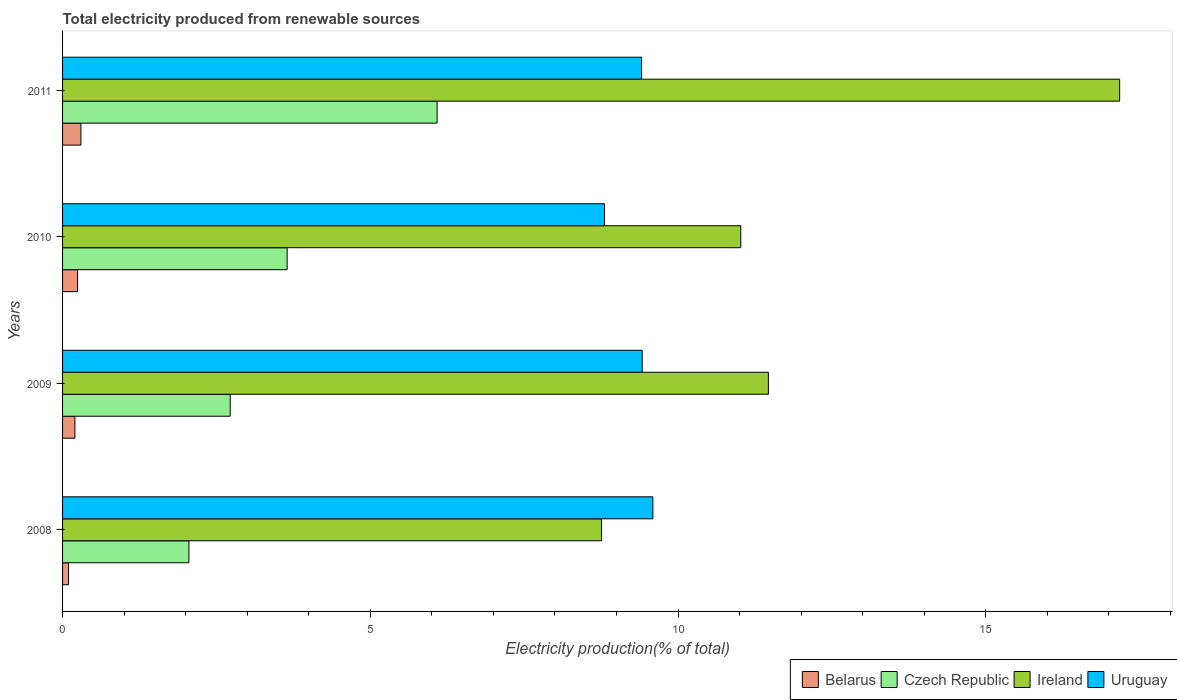How many different coloured bars are there?
Your response must be concise. 4. How many groups of bars are there?
Ensure brevity in your answer.  4. Are the number of bars per tick equal to the number of legend labels?
Your response must be concise. Yes. How many bars are there on the 3rd tick from the bottom?
Offer a terse response. 4. In how many cases, is the number of bars for a given year not equal to the number of legend labels?
Make the answer very short. 0. What is the total electricity produced in Ireland in 2011?
Offer a terse response. 17.17. Across all years, what is the maximum total electricity produced in Ireland?
Make the answer very short. 17.17. Across all years, what is the minimum total electricity produced in Ireland?
Offer a very short reply. 8.76. In which year was the total electricity produced in Belarus maximum?
Keep it short and to the point. 2011. In which year was the total electricity produced in Ireland minimum?
Offer a very short reply. 2008. What is the total total electricity produced in Ireland in the graph?
Provide a short and direct response. 48.42. What is the difference between the total electricity produced in Czech Republic in 2009 and that in 2010?
Give a very brief answer. -0.93. What is the difference between the total electricity produced in Uruguay in 2010 and the total electricity produced in Ireland in 2009?
Offer a very short reply. -2.66. What is the average total electricity produced in Ireland per year?
Your response must be concise. 12.1. In the year 2008, what is the difference between the total electricity produced in Ireland and total electricity produced in Belarus?
Your answer should be very brief. 8.66. What is the ratio of the total electricity produced in Belarus in 2008 to that in 2011?
Ensure brevity in your answer.  0.33. What is the difference between the highest and the second highest total electricity produced in Belarus?
Make the answer very short. 0.05. What is the difference between the highest and the lowest total electricity produced in Czech Republic?
Your answer should be compact. 4.03. What does the 3rd bar from the top in 2009 represents?
Keep it short and to the point. Czech Republic. What does the 4th bar from the bottom in 2008 represents?
Your answer should be very brief. Uruguay. Are all the bars in the graph horizontal?
Your answer should be very brief. Yes. How many years are there in the graph?
Give a very brief answer. 4. What is the difference between two consecutive major ticks on the X-axis?
Offer a terse response. 5. Does the graph contain any zero values?
Offer a terse response. No. How are the legend labels stacked?
Make the answer very short. Horizontal. What is the title of the graph?
Keep it short and to the point. Total electricity produced from renewable sources. Does "St. Lucia" appear as one of the legend labels in the graph?
Ensure brevity in your answer.  No. What is the Electricity production(% of total) in Belarus in 2008?
Provide a succinct answer. 0.1. What is the Electricity production(% of total) of Czech Republic in 2008?
Your answer should be very brief. 2.05. What is the Electricity production(% of total) in Ireland in 2008?
Provide a short and direct response. 8.76. What is the Electricity production(% of total) of Uruguay in 2008?
Keep it short and to the point. 9.59. What is the Electricity production(% of total) in Belarus in 2009?
Ensure brevity in your answer.  0.2. What is the Electricity production(% of total) of Czech Republic in 2009?
Give a very brief answer. 2.72. What is the Electricity production(% of total) in Ireland in 2009?
Your response must be concise. 11.47. What is the Electricity production(% of total) of Uruguay in 2009?
Keep it short and to the point. 9.42. What is the Electricity production(% of total) of Belarus in 2010?
Provide a short and direct response. 0.24. What is the Electricity production(% of total) of Czech Republic in 2010?
Keep it short and to the point. 3.65. What is the Electricity production(% of total) of Ireland in 2010?
Your answer should be very brief. 11.02. What is the Electricity production(% of total) of Uruguay in 2010?
Ensure brevity in your answer.  8.8. What is the Electricity production(% of total) of Belarus in 2011?
Give a very brief answer. 0.3. What is the Electricity production(% of total) in Czech Republic in 2011?
Ensure brevity in your answer.  6.08. What is the Electricity production(% of total) in Ireland in 2011?
Make the answer very short. 17.17. What is the Electricity production(% of total) in Uruguay in 2011?
Offer a terse response. 9.41. Across all years, what is the maximum Electricity production(% of total) in Belarus?
Ensure brevity in your answer.  0.3. Across all years, what is the maximum Electricity production(% of total) in Czech Republic?
Offer a terse response. 6.08. Across all years, what is the maximum Electricity production(% of total) of Ireland?
Keep it short and to the point. 17.17. Across all years, what is the maximum Electricity production(% of total) of Uruguay?
Offer a very short reply. 9.59. Across all years, what is the minimum Electricity production(% of total) in Belarus?
Give a very brief answer. 0.1. Across all years, what is the minimum Electricity production(% of total) of Czech Republic?
Your answer should be compact. 2.05. Across all years, what is the minimum Electricity production(% of total) of Ireland?
Keep it short and to the point. 8.76. Across all years, what is the minimum Electricity production(% of total) in Uruguay?
Provide a short and direct response. 8.8. What is the total Electricity production(% of total) in Belarus in the graph?
Your response must be concise. 0.84. What is the total Electricity production(% of total) in Czech Republic in the graph?
Your answer should be very brief. 14.51. What is the total Electricity production(% of total) of Ireland in the graph?
Keep it short and to the point. 48.42. What is the total Electricity production(% of total) of Uruguay in the graph?
Your answer should be very brief. 37.22. What is the difference between the Electricity production(% of total) of Belarus in 2008 and that in 2009?
Your answer should be compact. -0.1. What is the difference between the Electricity production(% of total) of Czech Republic in 2008 and that in 2009?
Ensure brevity in your answer.  -0.67. What is the difference between the Electricity production(% of total) of Ireland in 2008 and that in 2009?
Offer a very short reply. -2.71. What is the difference between the Electricity production(% of total) in Uruguay in 2008 and that in 2009?
Provide a succinct answer. 0.17. What is the difference between the Electricity production(% of total) in Belarus in 2008 and that in 2010?
Your answer should be very brief. -0.15. What is the difference between the Electricity production(% of total) of Czech Republic in 2008 and that in 2010?
Provide a succinct answer. -1.6. What is the difference between the Electricity production(% of total) of Ireland in 2008 and that in 2010?
Your answer should be very brief. -2.26. What is the difference between the Electricity production(% of total) in Uruguay in 2008 and that in 2010?
Your answer should be very brief. 0.79. What is the difference between the Electricity production(% of total) in Belarus in 2008 and that in 2011?
Your answer should be compact. -0.2. What is the difference between the Electricity production(% of total) in Czech Republic in 2008 and that in 2011?
Provide a succinct answer. -4.03. What is the difference between the Electricity production(% of total) of Ireland in 2008 and that in 2011?
Provide a succinct answer. -8.42. What is the difference between the Electricity production(% of total) of Uruguay in 2008 and that in 2011?
Give a very brief answer. 0.18. What is the difference between the Electricity production(% of total) in Belarus in 2009 and that in 2010?
Your answer should be very brief. -0.04. What is the difference between the Electricity production(% of total) in Czech Republic in 2009 and that in 2010?
Offer a very short reply. -0.93. What is the difference between the Electricity production(% of total) in Ireland in 2009 and that in 2010?
Offer a terse response. 0.45. What is the difference between the Electricity production(% of total) of Uruguay in 2009 and that in 2010?
Provide a short and direct response. 0.61. What is the difference between the Electricity production(% of total) of Belarus in 2009 and that in 2011?
Your answer should be compact. -0.1. What is the difference between the Electricity production(% of total) of Czech Republic in 2009 and that in 2011?
Provide a short and direct response. -3.36. What is the difference between the Electricity production(% of total) in Ireland in 2009 and that in 2011?
Give a very brief answer. -5.71. What is the difference between the Electricity production(% of total) of Uruguay in 2009 and that in 2011?
Your response must be concise. 0.01. What is the difference between the Electricity production(% of total) in Belarus in 2010 and that in 2011?
Ensure brevity in your answer.  -0.05. What is the difference between the Electricity production(% of total) in Czech Republic in 2010 and that in 2011?
Offer a very short reply. -2.44. What is the difference between the Electricity production(% of total) of Ireland in 2010 and that in 2011?
Ensure brevity in your answer.  -6.16. What is the difference between the Electricity production(% of total) in Uruguay in 2010 and that in 2011?
Provide a short and direct response. -0.6. What is the difference between the Electricity production(% of total) in Belarus in 2008 and the Electricity production(% of total) in Czech Republic in 2009?
Provide a succinct answer. -2.63. What is the difference between the Electricity production(% of total) in Belarus in 2008 and the Electricity production(% of total) in Ireland in 2009?
Provide a succinct answer. -11.37. What is the difference between the Electricity production(% of total) of Belarus in 2008 and the Electricity production(% of total) of Uruguay in 2009?
Give a very brief answer. -9.32. What is the difference between the Electricity production(% of total) of Czech Republic in 2008 and the Electricity production(% of total) of Ireland in 2009?
Your response must be concise. -9.41. What is the difference between the Electricity production(% of total) of Czech Republic in 2008 and the Electricity production(% of total) of Uruguay in 2009?
Offer a very short reply. -7.36. What is the difference between the Electricity production(% of total) of Ireland in 2008 and the Electricity production(% of total) of Uruguay in 2009?
Make the answer very short. -0.66. What is the difference between the Electricity production(% of total) in Belarus in 2008 and the Electricity production(% of total) in Czech Republic in 2010?
Keep it short and to the point. -3.55. What is the difference between the Electricity production(% of total) of Belarus in 2008 and the Electricity production(% of total) of Ireland in 2010?
Offer a very short reply. -10.92. What is the difference between the Electricity production(% of total) of Belarus in 2008 and the Electricity production(% of total) of Uruguay in 2010?
Your answer should be compact. -8.71. What is the difference between the Electricity production(% of total) of Czech Republic in 2008 and the Electricity production(% of total) of Ireland in 2010?
Offer a terse response. -8.97. What is the difference between the Electricity production(% of total) of Czech Republic in 2008 and the Electricity production(% of total) of Uruguay in 2010?
Offer a terse response. -6.75. What is the difference between the Electricity production(% of total) in Ireland in 2008 and the Electricity production(% of total) in Uruguay in 2010?
Offer a very short reply. -0.05. What is the difference between the Electricity production(% of total) of Belarus in 2008 and the Electricity production(% of total) of Czech Republic in 2011?
Your answer should be compact. -5.99. What is the difference between the Electricity production(% of total) in Belarus in 2008 and the Electricity production(% of total) in Ireland in 2011?
Your response must be concise. -17.08. What is the difference between the Electricity production(% of total) of Belarus in 2008 and the Electricity production(% of total) of Uruguay in 2011?
Make the answer very short. -9.31. What is the difference between the Electricity production(% of total) in Czech Republic in 2008 and the Electricity production(% of total) in Ireland in 2011?
Offer a very short reply. -15.12. What is the difference between the Electricity production(% of total) in Czech Republic in 2008 and the Electricity production(% of total) in Uruguay in 2011?
Your answer should be compact. -7.35. What is the difference between the Electricity production(% of total) of Ireland in 2008 and the Electricity production(% of total) of Uruguay in 2011?
Provide a short and direct response. -0.65. What is the difference between the Electricity production(% of total) of Belarus in 2009 and the Electricity production(% of total) of Czech Republic in 2010?
Your answer should be compact. -3.45. What is the difference between the Electricity production(% of total) in Belarus in 2009 and the Electricity production(% of total) in Ireland in 2010?
Give a very brief answer. -10.82. What is the difference between the Electricity production(% of total) of Belarus in 2009 and the Electricity production(% of total) of Uruguay in 2010?
Provide a succinct answer. -8.6. What is the difference between the Electricity production(% of total) in Czech Republic in 2009 and the Electricity production(% of total) in Ireland in 2010?
Ensure brevity in your answer.  -8.29. What is the difference between the Electricity production(% of total) of Czech Republic in 2009 and the Electricity production(% of total) of Uruguay in 2010?
Ensure brevity in your answer.  -6.08. What is the difference between the Electricity production(% of total) of Ireland in 2009 and the Electricity production(% of total) of Uruguay in 2010?
Your answer should be compact. 2.66. What is the difference between the Electricity production(% of total) of Belarus in 2009 and the Electricity production(% of total) of Czech Republic in 2011?
Ensure brevity in your answer.  -5.88. What is the difference between the Electricity production(% of total) of Belarus in 2009 and the Electricity production(% of total) of Ireland in 2011?
Keep it short and to the point. -16.97. What is the difference between the Electricity production(% of total) of Belarus in 2009 and the Electricity production(% of total) of Uruguay in 2011?
Your response must be concise. -9.21. What is the difference between the Electricity production(% of total) of Czech Republic in 2009 and the Electricity production(% of total) of Ireland in 2011?
Your response must be concise. -14.45. What is the difference between the Electricity production(% of total) of Czech Republic in 2009 and the Electricity production(% of total) of Uruguay in 2011?
Offer a terse response. -6.68. What is the difference between the Electricity production(% of total) in Ireland in 2009 and the Electricity production(% of total) in Uruguay in 2011?
Ensure brevity in your answer.  2.06. What is the difference between the Electricity production(% of total) in Belarus in 2010 and the Electricity production(% of total) in Czech Republic in 2011?
Your response must be concise. -5.84. What is the difference between the Electricity production(% of total) of Belarus in 2010 and the Electricity production(% of total) of Ireland in 2011?
Keep it short and to the point. -16.93. What is the difference between the Electricity production(% of total) in Belarus in 2010 and the Electricity production(% of total) in Uruguay in 2011?
Ensure brevity in your answer.  -9.16. What is the difference between the Electricity production(% of total) in Czech Republic in 2010 and the Electricity production(% of total) in Ireland in 2011?
Make the answer very short. -13.53. What is the difference between the Electricity production(% of total) of Czech Republic in 2010 and the Electricity production(% of total) of Uruguay in 2011?
Provide a succinct answer. -5.76. What is the difference between the Electricity production(% of total) in Ireland in 2010 and the Electricity production(% of total) in Uruguay in 2011?
Offer a very short reply. 1.61. What is the average Electricity production(% of total) in Belarus per year?
Offer a very short reply. 0.21. What is the average Electricity production(% of total) in Czech Republic per year?
Your answer should be very brief. 3.63. What is the average Electricity production(% of total) of Ireland per year?
Your response must be concise. 12.1. What is the average Electricity production(% of total) of Uruguay per year?
Your answer should be compact. 9.3. In the year 2008, what is the difference between the Electricity production(% of total) of Belarus and Electricity production(% of total) of Czech Republic?
Provide a short and direct response. -1.96. In the year 2008, what is the difference between the Electricity production(% of total) in Belarus and Electricity production(% of total) in Ireland?
Provide a succinct answer. -8.66. In the year 2008, what is the difference between the Electricity production(% of total) in Belarus and Electricity production(% of total) in Uruguay?
Keep it short and to the point. -9.49. In the year 2008, what is the difference between the Electricity production(% of total) of Czech Republic and Electricity production(% of total) of Ireland?
Your response must be concise. -6.7. In the year 2008, what is the difference between the Electricity production(% of total) in Czech Republic and Electricity production(% of total) in Uruguay?
Provide a short and direct response. -7.54. In the year 2008, what is the difference between the Electricity production(% of total) of Ireland and Electricity production(% of total) of Uruguay?
Ensure brevity in your answer.  -0.83. In the year 2009, what is the difference between the Electricity production(% of total) in Belarus and Electricity production(% of total) in Czech Republic?
Make the answer very short. -2.52. In the year 2009, what is the difference between the Electricity production(% of total) of Belarus and Electricity production(% of total) of Ireland?
Make the answer very short. -11.27. In the year 2009, what is the difference between the Electricity production(% of total) of Belarus and Electricity production(% of total) of Uruguay?
Your response must be concise. -9.22. In the year 2009, what is the difference between the Electricity production(% of total) of Czech Republic and Electricity production(% of total) of Ireland?
Provide a short and direct response. -8.74. In the year 2009, what is the difference between the Electricity production(% of total) in Czech Republic and Electricity production(% of total) in Uruguay?
Provide a short and direct response. -6.69. In the year 2009, what is the difference between the Electricity production(% of total) of Ireland and Electricity production(% of total) of Uruguay?
Your response must be concise. 2.05. In the year 2010, what is the difference between the Electricity production(% of total) in Belarus and Electricity production(% of total) in Czech Republic?
Make the answer very short. -3.41. In the year 2010, what is the difference between the Electricity production(% of total) in Belarus and Electricity production(% of total) in Ireland?
Provide a succinct answer. -10.77. In the year 2010, what is the difference between the Electricity production(% of total) of Belarus and Electricity production(% of total) of Uruguay?
Your answer should be very brief. -8.56. In the year 2010, what is the difference between the Electricity production(% of total) in Czech Republic and Electricity production(% of total) in Ireland?
Ensure brevity in your answer.  -7.37. In the year 2010, what is the difference between the Electricity production(% of total) in Czech Republic and Electricity production(% of total) in Uruguay?
Ensure brevity in your answer.  -5.16. In the year 2010, what is the difference between the Electricity production(% of total) of Ireland and Electricity production(% of total) of Uruguay?
Offer a very short reply. 2.21. In the year 2011, what is the difference between the Electricity production(% of total) of Belarus and Electricity production(% of total) of Czech Republic?
Your answer should be very brief. -5.79. In the year 2011, what is the difference between the Electricity production(% of total) of Belarus and Electricity production(% of total) of Ireland?
Provide a succinct answer. -16.88. In the year 2011, what is the difference between the Electricity production(% of total) in Belarus and Electricity production(% of total) in Uruguay?
Give a very brief answer. -9.11. In the year 2011, what is the difference between the Electricity production(% of total) in Czech Republic and Electricity production(% of total) in Ireland?
Offer a very short reply. -11.09. In the year 2011, what is the difference between the Electricity production(% of total) in Czech Republic and Electricity production(% of total) in Uruguay?
Offer a terse response. -3.32. In the year 2011, what is the difference between the Electricity production(% of total) in Ireland and Electricity production(% of total) in Uruguay?
Your answer should be very brief. 7.77. What is the ratio of the Electricity production(% of total) of Belarus in 2008 to that in 2009?
Ensure brevity in your answer.  0.48. What is the ratio of the Electricity production(% of total) in Czech Republic in 2008 to that in 2009?
Offer a very short reply. 0.75. What is the ratio of the Electricity production(% of total) in Ireland in 2008 to that in 2009?
Make the answer very short. 0.76. What is the ratio of the Electricity production(% of total) in Uruguay in 2008 to that in 2009?
Your response must be concise. 1.02. What is the ratio of the Electricity production(% of total) in Belarus in 2008 to that in 2010?
Provide a short and direct response. 0.4. What is the ratio of the Electricity production(% of total) of Czech Republic in 2008 to that in 2010?
Provide a succinct answer. 0.56. What is the ratio of the Electricity production(% of total) in Ireland in 2008 to that in 2010?
Keep it short and to the point. 0.79. What is the ratio of the Electricity production(% of total) of Uruguay in 2008 to that in 2010?
Give a very brief answer. 1.09. What is the ratio of the Electricity production(% of total) in Belarus in 2008 to that in 2011?
Your response must be concise. 0.33. What is the ratio of the Electricity production(% of total) of Czech Republic in 2008 to that in 2011?
Provide a succinct answer. 0.34. What is the ratio of the Electricity production(% of total) in Ireland in 2008 to that in 2011?
Your response must be concise. 0.51. What is the ratio of the Electricity production(% of total) of Uruguay in 2008 to that in 2011?
Make the answer very short. 1.02. What is the ratio of the Electricity production(% of total) of Belarus in 2009 to that in 2010?
Your answer should be compact. 0.82. What is the ratio of the Electricity production(% of total) in Czech Republic in 2009 to that in 2010?
Your response must be concise. 0.75. What is the ratio of the Electricity production(% of total) in Ireland in 2009 to that in 2010?
Your response must be concise. 1.04. What is the ratio of the Electricity production(% of total) in Uruguay in 2009 to that in 2010?
Provide a succinct answer. 1.07. What is the ratio of the Electricity production(% of total) in Belarus in 2009 to that in 2011?
Your answer should be very brief. 0.67. What is the ratio of the Electricity production(% of total) in Czech Republic in 2009 to that in 2011?
Ensure brevity in your answer.  0.45. What is the ratio of the Electricity production(% of total) in Ireland in 2009 to that in 2011?
Your response must be concise. 0.67. What is the ratio of the Electricity production(% of total) in Uruguay in 2009 to that in 2011?
Your answer should be very brief. 1. What is the ratio of the Electricity production(% of total) of Belarus in 2010 to that in 2011?
Provide a short and direct response. 0.82. What is the ratio of the Electricity production(% of total) in Czech Republic in 2010 to that in 2011?
Your answer should be compact. 0.6. What is the ratio of the Electricity production(% of total) in Ireland in 2010 to that in 2011?
Your response must be concise. 0.64. What is the ratio of the Electricity production(% of total) in Uruguay in 2010 to that in 2011?
Give a very brief answer. 0.94. What is the difference between the highest and the second highest Electricity production(% of total) in Belarus?
Ensure brevity in your answer.  0.05. What is the difference between the highest and the second highest Electricity production(% of total) in Czech Republic?
Offer a terse response. 2.44. What is the difference between the highest and the second highest Electricity production(% of total) in Ireland?
Your response must be concise. 5.71. What is the difference between the highest and the second highest Electricity production(% of total) in Uruguay?
Offer a very short reply. 0.17. What is the difference between the highest and the lowest Electricity production(% of total) in Belarus?
Provide a succinct answer. 0.2. What is the difference between the highest and the lowest Electricity production(% of total) in Czech Republic?
Offer a very short reply. 4.03. What is the difference between the highest and the lowest Electricity production(% of total) in Ireland?
Your answer should be compact. 8.42. What is the difference between the highest and the lowest Electricity production(% of total) in Uruguay?
Offer a terse response. 0.79. 